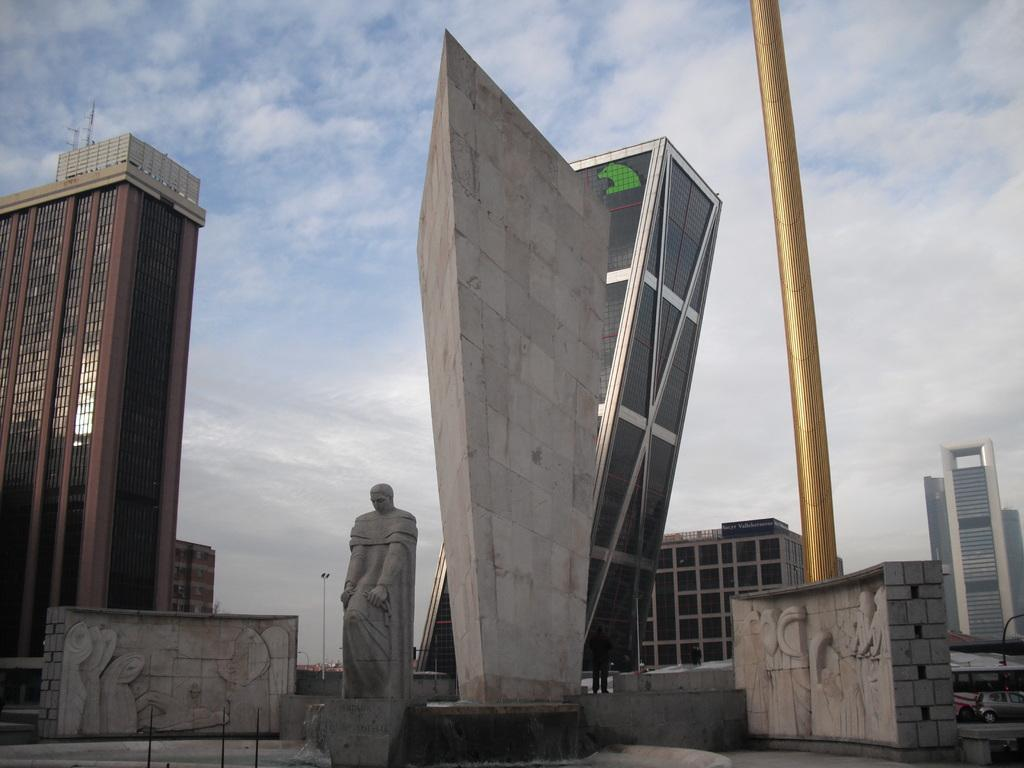What type of buildings can be seen on both sides of the image? There are skyscrapers on both the right and left sides of the image. What is located on the right side of the image besides the skyscrapers? There is a pole on the right side of the image. What is the main subject in the center of the image? There is a statue in the center of the image. Where is the playground located in the image? There is no playground present in the image. What type of maid is depicted in the statue? The image does not depict a statue of a maid; it features a statue as the main subject in the center of the image. 